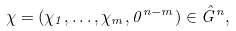<formula> <loc_0><loc_0><loc_500><loc_500>\chi = ( \chi _ { 1 } , \dots , \chi _ { m } , 0 ^ { n - m } ) \in \hat { G } ^ { n } ,</formula> 